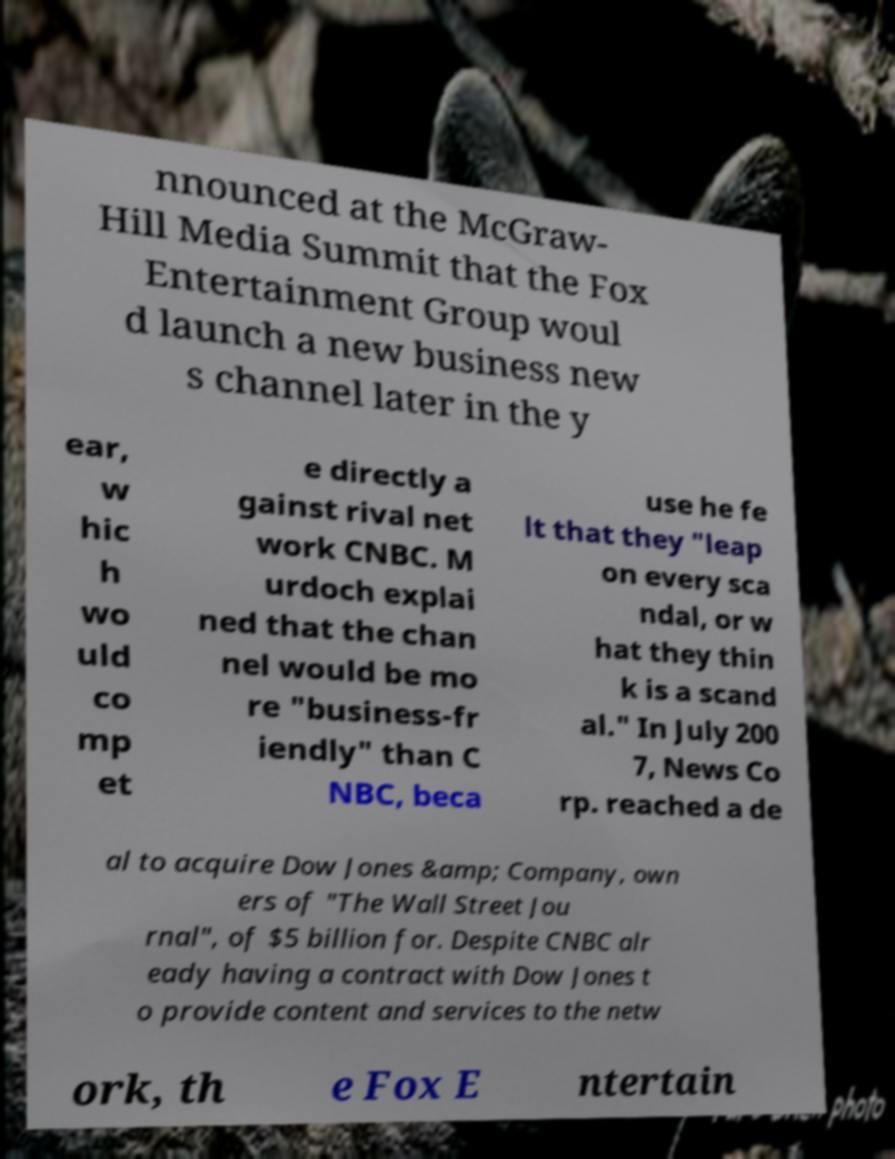There's text embedded in this image that I need extracted. Can you transcribe it verbatim? nnounced at the McGraw- Hill Media Summit that the Fox Entertainment Group woul d launch a new business new s channel later in the y ear, w hic h wo uld co mp et e directly a gainst rival net work CNBC. M urdoch explai ned that the chan nel would be mo re "business-fr iendly" than C NBC, beca use he fe lt that they "leap on every sca ndal, or w hat they thin k is a scand al." In July 200 7, News Co rp. reached a de al to acquire Dow Jones &amp; Company, own ers of "The Wall Street Jou rnal", of $5 billion for. Despite CNBC alr eady having a contract with Dow Jones t o provide content and services to the netw ork, th e Fox E ntertain 